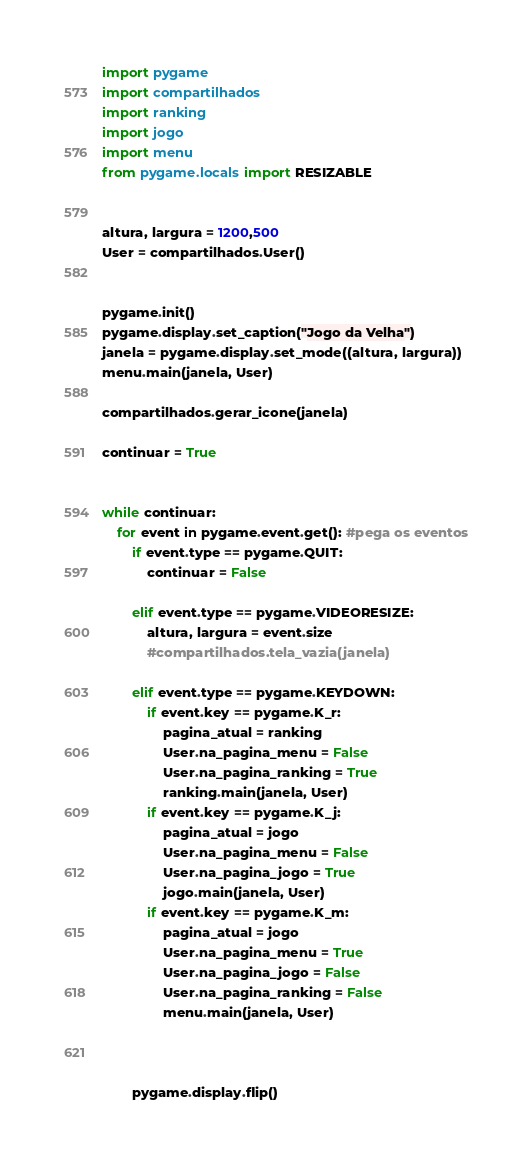<code> <loc_0><loc_0><loc_500><loc_500><_Python_>import pygame
import compartilhados
import ranking
import jogo
import menu
from pygame.locals import RESIZABLE


altura, largura = 1200,500
User = compartilhados.User()


pygame.init()
pygame.display.set_caption("Jogo da Velha")
janela = pygame.display.set_mode((altura, largura))
menu.main(janela, User)

compartilhados.gerar_icone(janela)

continuar = True


while continuar:
    for event in pygame.event.get(): #pega os eventos
        if event.type == pygame.QUIT:
            continuar = False

        elif event.type == pygame.VIDEORESIZE:
            altura, largura = event.size
            #compartilhados.tela_vazia(janela)

        elif event.type == pygame.KEYDOWN:
            if event.key == pygame.K_r:
                pagina_atual = ranking
                User.na_pagina_menu = False
                User.na_pagina_ranking = True
                ranking.main(janela, User)
            if event.key == pygame.K_j:
                pagina_atual = jogo
                User.na_pagina_menu = False
                User.na_pagina_jogo = True
                jogo.main(janela, User)
            if event.key == pygame.K_m:
                pagina_atual = jogo
                User.na_pagina_menu = True
                User.na_pagina_jogo = False
                User.na_pagina_ranking = False
                menu.main(janela, User)

                    
        
        pygame.display.flip()</code> 